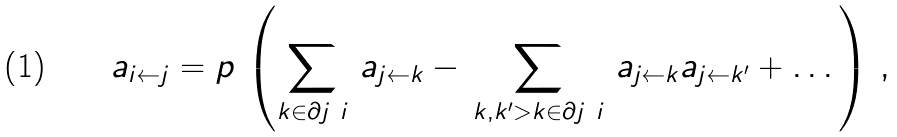<formula> <loc_0><loc_0><loc_500><loc_500>\, a _ { i \leftarrow j } = p \, \left ( \sum _ { k \in \partial j \ i } \, a _ { j \leftarrow k } - \, \sum _ { k , k ^ { \prime } > k \in \partial j \ i } \, a _ { j \leftarrow k } a _ { j \leftarrow k ^ { \prime } } + \dots \, \right ) \, ,</formula> 